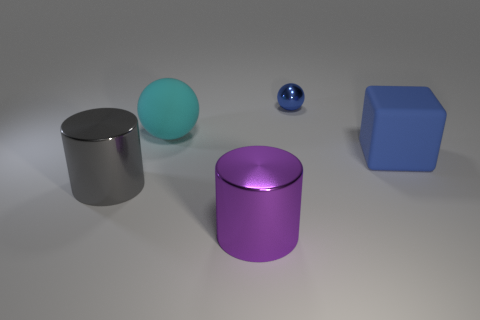Is there anything else that has the same color as the matte sphere?
Offer a very short reply. No. There is a gray thing that is in front of the rubber thing that is behind the large blue rubber object; are there any large cyan rubber things that are in front of it?
Your answer should be very brief. No. There is a matte thing that is behind the blue matte thing; is its color the same as the object that is on the right side of the small blue object?
Your answer should be very brief. No. What material is the purple thing that is the same size as the gray cylinder?
Make the answer very short. Metal. What is the size of the metallic thing behind the blue object in front of the ball that is on the right side of the large purple object?
Your answer should be very brief. Small. What number of other things are made of the same material as the blue block?
Provide a short and direct response. 1. How big is the cylinder to the left of the large sphere?
Provide a short and direct response. Large. How many metal objects are both behind the gray cylinder and to the left of the small blue object?
Your answer should be compact. 0. There is a big thing behind the blue object in front of the blue ball; what is it made of?
Give a very brief answer. Rubber. There is another big thing that is the same shape as the purple object; what is it made of?
Your response must be concise. Metal. 